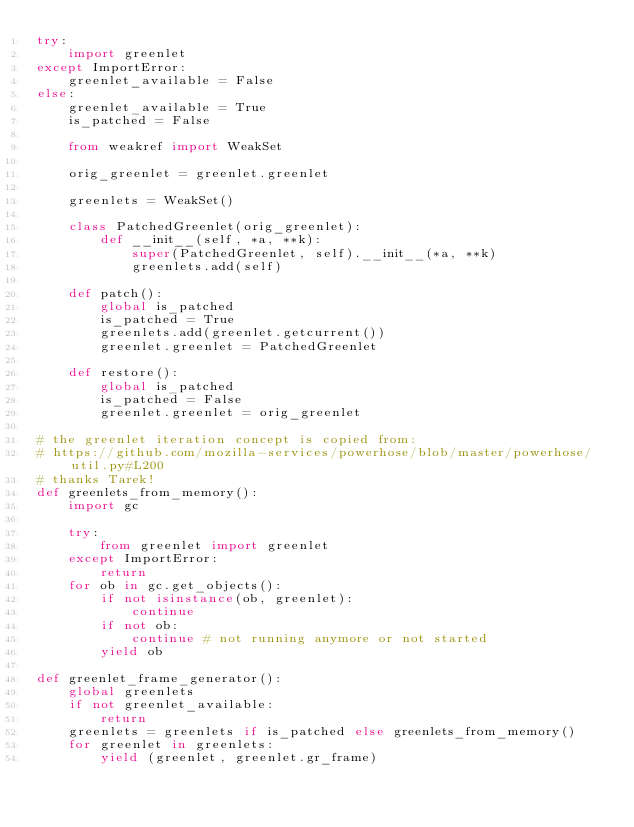Convert code to text. <code><loc_0><loc_0><loc_500><loc_500><_Python_>try:
    import greenlet
except ImportError:
    greenlet_available = False
else:
    greenlet_available = True
    is_patched = False

    from weakref import WeakSet

    orig_greenlet = greenlet.greenlet

    greenlets = WeakSet()

    class PatchedGreenlet(orig_greenlet):
        def __init__(self, *a, **k):
            super(PatchedGreenlet, self).__init__(*a, **k)
            greenlets.add(self)

    def patch():
        global is_patched
        is_patched = True
        greenlets.add(greenlet.getcurrent())
        greenlet.greenlet = PatchedGreenlet

    def restore():
        global is_patched
        is_patched = False
        greenlet.greenlet = orig_greenlet

# the greenlet iteration concept is copied from:
# https://github.com/mozilla-services/powerhose/blob/master/powerhose/util.py#L200
# thanks Tarek!
def greenlets_from_memory():
    import gc

    try:
        from greenlet import greenlet
    except ImportError:
        return
    for ob in gc.get_objects():
        if not isinstance(ob, greenlet):
            continue
        if not ob:
            continue # not running anymore or not started
        yield ob

def greenlet_frame_generator():
    global greenlets
    if not greenlet_available:
        return
    greenlets = greenlets if is_patched else greenlets_from_memory()
    for greenlet in greenlets:
        yield (greenlet, greenlet.gr_frame)
</code> 